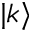Convert formula to latex. <formula><loc_0><loc_0><loc_500><loc_500>| k \rangle</formula> 